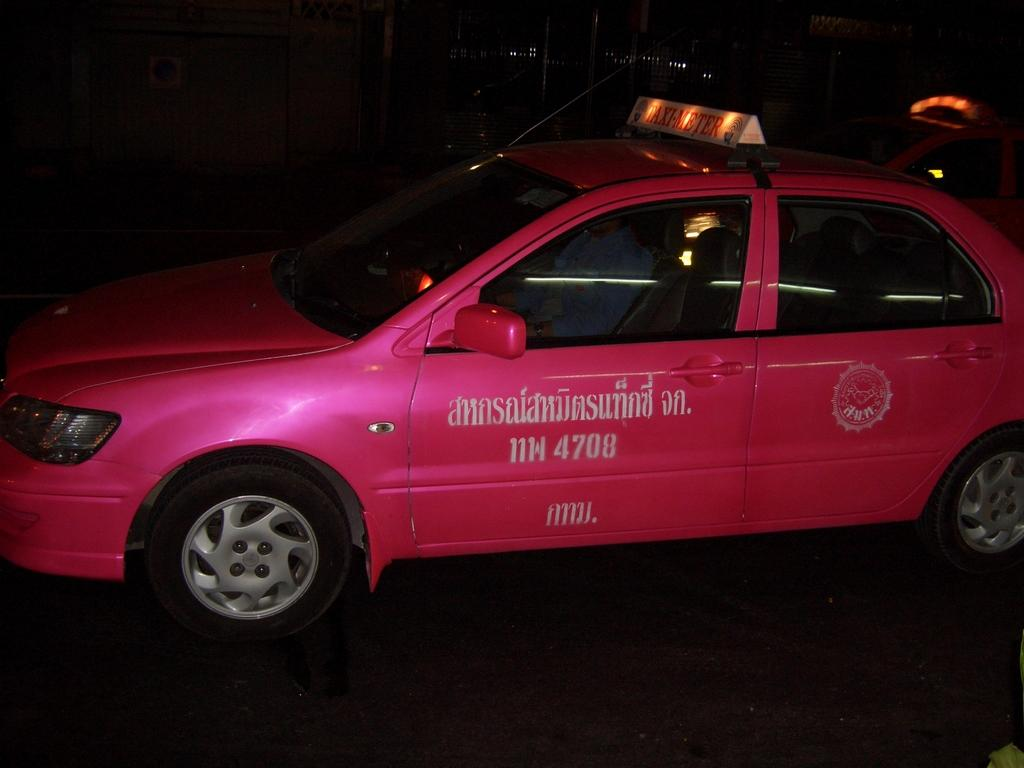What is the person in the image doing? There is a person sitting inside a vehicle in the image. What can be seen on the signboard in the image? There is a signboard with text in the image. What type of text is placed on the ground in the image? There is text placed on the ground in the image. What is visible in the background of the image? There is a vehicle and lights visible in the background of the image. Can you see the ocean in the background of the image? No, the ocean is not present in the image. 